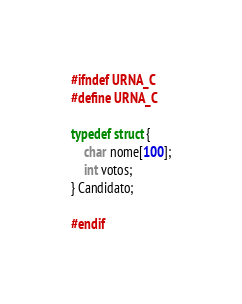<code> <loc_0><loc_0><loc_500><loc_500><_C_>#ifndef URNA_C
#define URNA_C

typedef struct {
    char nome[100];
    int votos;
} Candidato;

#endif
</code> 